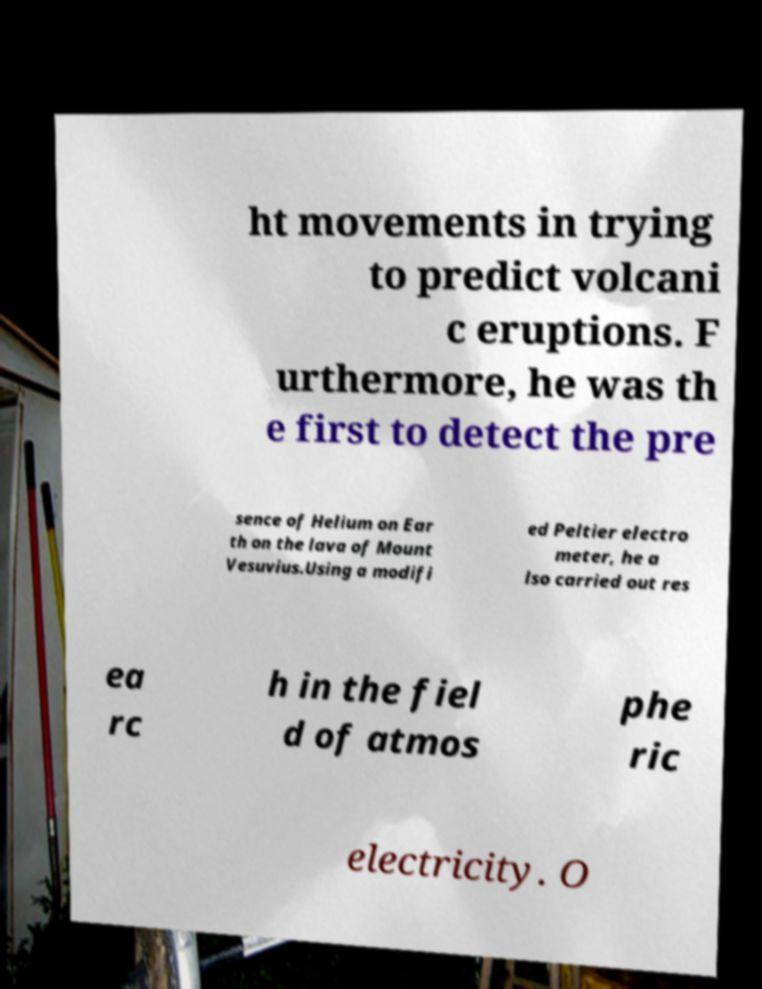I need the written content from this picture converted into text. Can you do that? ht movements in trying to predict volcani c eruptions. F urthermore, he was th e first to detect the pre sence of Helium on Ear th on the lava of Mount Vesuvius.Using a modifi ed Peltier electro meter, he a lso carried out res ea rc h in the fiel d of atmos phe ric electricity. O 